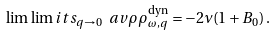Convert formula to latex. <formula><loc_0><loc_0><loc_500><loc_500>\lim \lim i t s _ { q \rightarrow 0 } \ a v { \rho \rho } _ { \omega , q } ^ { \text {dyn} } = - 2 \nu ( 1 + B _ { 0 } ) \, .</formula> 